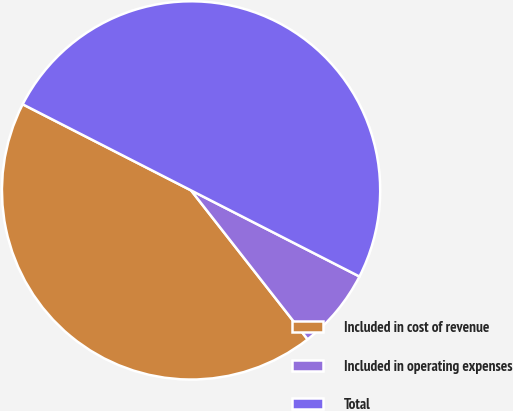<chart> <loc_0><loc_0><loc_500><loc_500><pie_chart><fcel>Included in cost of revenue<fcel>Included in operating expenses<fcel>Total<nl><fcel>43.09%<fcel>6.91%<fcel>50.0%<nl></chart> 